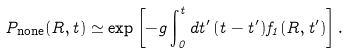Convert formula to latex. <formula><loc_0><loc_0><loc_500><loc_500>P _ { \text {none} } ( R , t ) \simeq \exp \left [ - g \int _ { 0 } ^ { t } d t ^ { \prime } \, ( t - t ^ { \prime } ) f _ { 1 } ( R , t ^ { \prime } ) \right ] .</formula> 